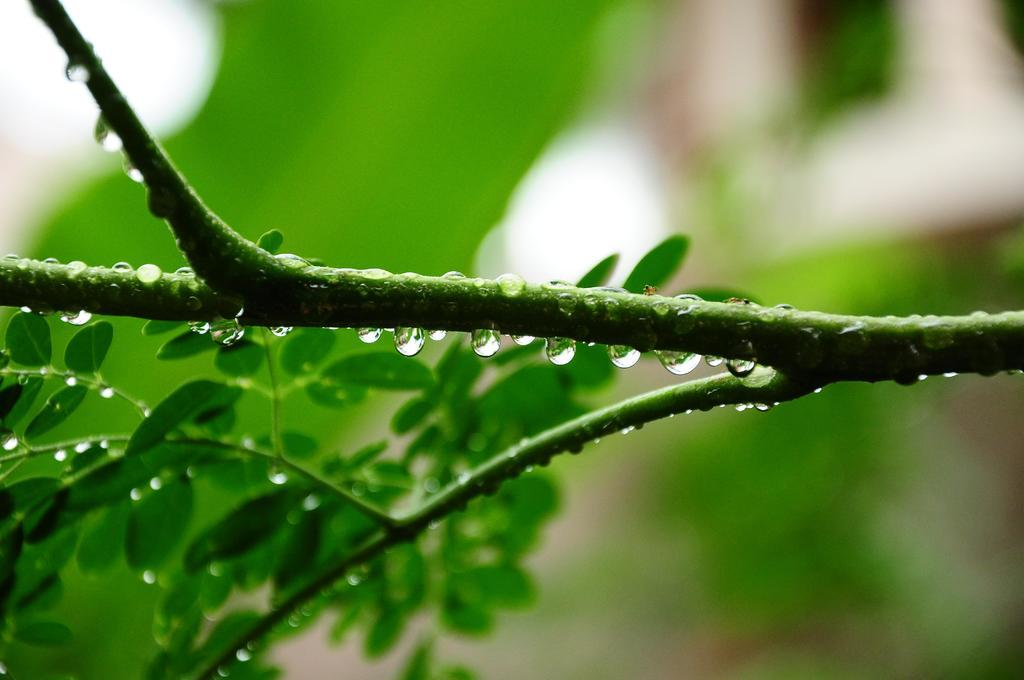What is the main object in the image? There is a branch in the image. What can be observed on the branch? The branch has water droplets on it and leaves. What type of collar can be seen on the branch in the image? There is no collar present on the branch in the image. 